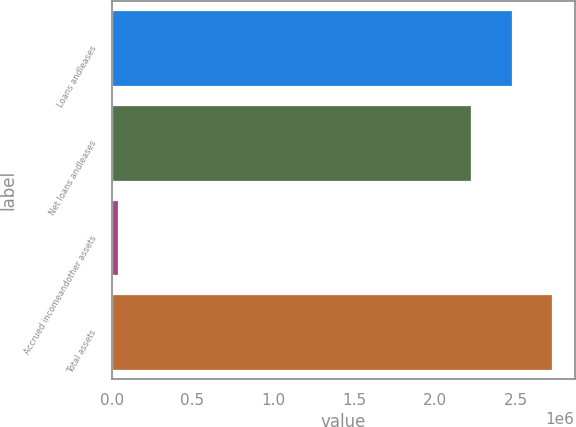Convert chart to OTSL. <chart><loc_0><loc_0><loc_500><loc_500><bar_chart><fcel>Loans andleases<fcel>Net loans andleases<fcel>Accrued incomeandother assets<fcel>Total assets<nl><fcel>2.47309e+06<fcel>2.22225e+06<fcel>39604<fcel>2.72392e+06<nl></chart> 